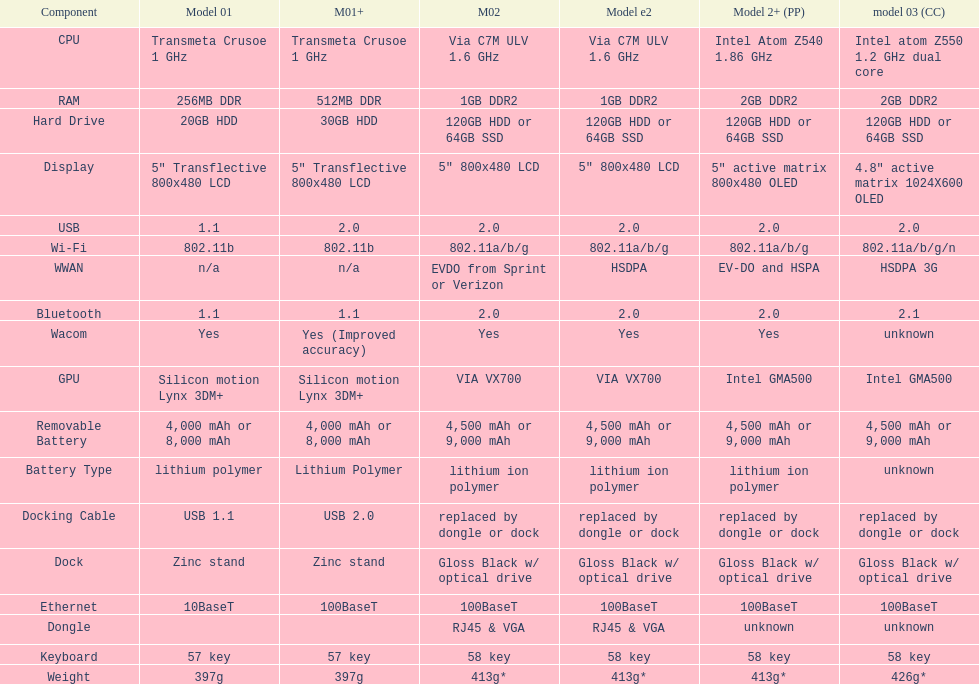How many models use a usb docking cable? 2. Can you parse all the data within this table? {'header': ['Component', 'Model 01', 'M01+', 'M02', 'Model e2', 'Model 2+ (PP)', 'model 03 (CC)'], 'rows': [['CPU', 'Transmeta Crusoe 1\xa0GHz', 'Transmeta Crusoe 1\xa0GHz', 'Via C7M ULV 1.6\xa0GHz', 'Via C7M ULV 1.6\xa0GHz', 'Intel Atom Z540 1.86\xa0GHz', 'Intel atom Z550 1.2\xa0GHz dual core'], ['RAM', '256MB DDR', '512MB DDR', '1GB DDR2', '1GB DDR2', '2GB DDR2', '2GB DDR2'], ['Hard Drive', '20GB HDD', '30GB HDD', '120GB HDD or 64GB SSD', '120GB HDD or 64GB SSD', '120GB HDD or 64GB SSD', '120GB HDD or 64GB SSD'], ['Display', '5" Transflective 800x480 LCD', '5" Transflective 800x480 LCD', '5" 800x480 LCD', '5" 800x480 LCD', '5" active matrix 800x480 OLED', '4.8" active matrix 1024X600 OLED'], ['USB', '1.1', '2.0', '2.0', '2.0', '2.0', '2.0'], ['Wi-Fi', '802.11b', '802.11b', '802.11a/b/g', '802.11a/b/g', '802.11a/b/g', '802.11a/b/g/n'], ['WWAN', 'n/a', 'n/a', 'EVDO from Sprint or Verizon', 'HSDPA', 'EV-DO and HSPA', 'HSDPA 3G'], ['Bluetooth', '1.1', '1.1', '2.0', '2.0', '2.0', '2.1'], ['Wacom', 'Yes', 'Yes (Improved accuracy)', 'Yes', 'Yes', 'Yes', 'unknown'], ['GPU', 'Silicon motion Lynx 3DM+', 'Silicon motion Lynx 3DM+', 'VIA VX700', 'VIA VX700', 'Intel GMA500', 'Intel GMA500'], ['Removable Battery', '4,000 mAh or 8,000 mAh', '4,000 mAh or 8,000 mAh', '4,500 mAh or 9,000 mAh', '4,500 mAh or 9,000 mAh', '4,500 mAh or 9,000 mAh', '4,500 mAh or 9,000 mAh'], ['Battery Type', 'lithium polymer', 'Lithium Polymer', 'lithium ion polymer', 'lithium ion polymer', 'lithium ion polymer', 'unknown'], ['Docking Cable', 'USB 1.1', 'USB 2.0', 'replaced by dongle or dock', 'replaced by dongle or dock', 'replaced by dongle or dock', 'replaced by dongle or dock'], ['Dock', 'Zinc stand', 'Zinc stand', 'Gloss Black w/ optical drive', 'Gloss Black w/ optical drive', 'Gloss Black w/ optical drive', 'Gloss Black w/ optical drive'], ['Ethernet', '10BaseT', '100BaseT', '100BaseT', '100BaseT', '100BaseT', '100BaseT'], ['Dongle', '', '', 'RJ45 & VGA', 'RJ45 & VGA', 'unknown', 'unknown'], ['Keyboard', '57 key', '57 key', '58 key', '58 key', '58 key', '58 key'], ['Weight', '397g', '397g', '413g*', '413g*', '413g*', '426g*']]} 